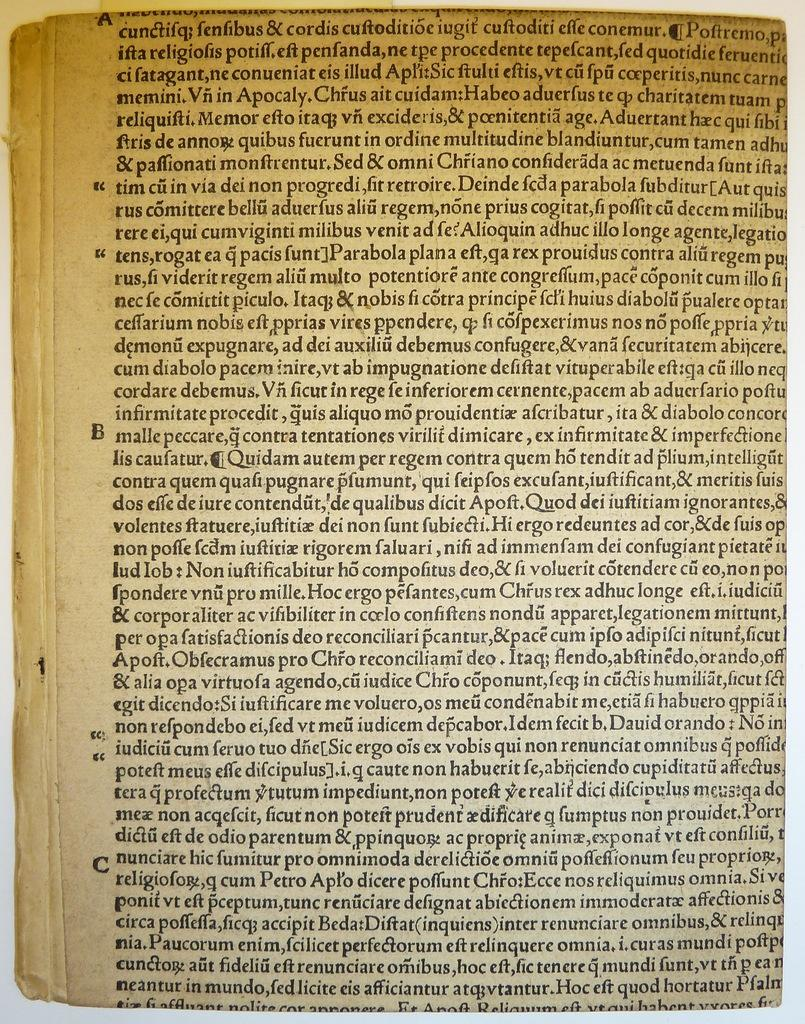<image>
Share a concise interpretation of the image provided. A page of this ancient book has section markers A, B, and C down the left margin. 